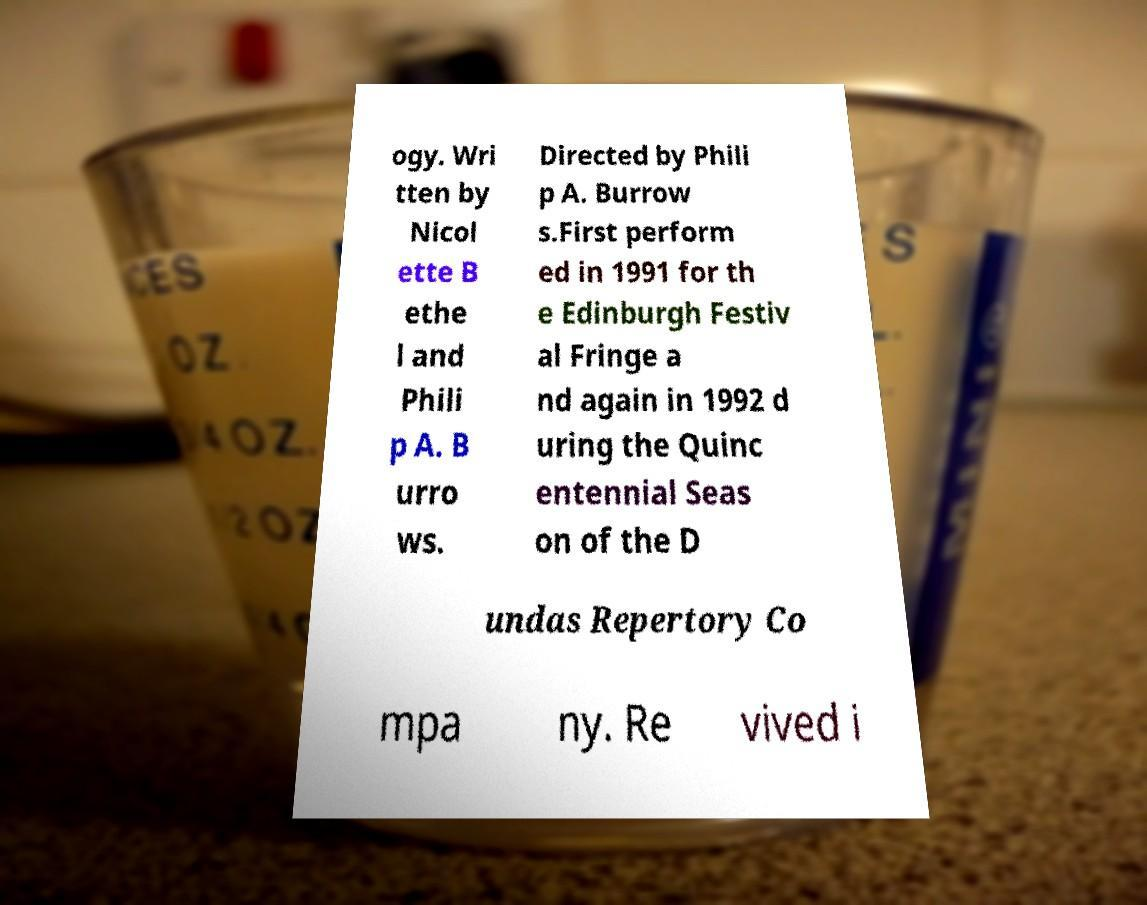What messages or text are displayed in this image? I need them in a readable, typed format. ogy. Wri tten by Nicol ette B ethe l and Phili p A. B urro ws. Directed by Phili p A. Burrow s.First perform ed in 1991 for th e Edinburgh Festiv al Fringe a nd again in 1992 d uring the Quinc entennial Seas on of the D undas Repertory Co mpa ny. Re vived i 